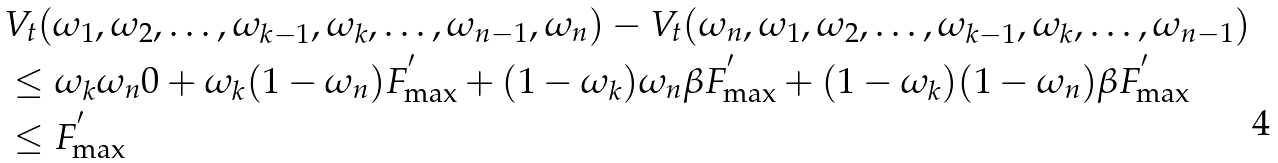<formula> <loc_0><loc_0><loc_500><loc_500>& V _ { t } ( \omega _ { 1 } , \omega _ { 2 } , \dots , \omega _ { k - 1 } , \omega _ { k } , \dots , \omega _ { n - 1 } , \omega _ { n } ) - V _ { t } ( \omega _ { n } , \omega _ { 1 } , \omega _ { 2 } , \dots , \omega _ { k - 1 } , \omega _ { k } , \dots , \omega _ { n - 1 } ) \\ & \leq \omega _ { k } \omega _ { n } 0 + \omega _ { k } ( 1 - \omega _ { n } ) F _ { \max } ^ { ^ { \prime } } + ( 1 - \omega _ { k } ) \omega _ { n } \beta F _ { \max } ^ { ^ { \prime } } + ( 1 - \omega _ { k } ) ( 1 - \omega _ { n } ) \beta F _ { \max } ^ { ^ { \prime } } \\ & \leq F _ { \max } ^ { ^ { \prime } }</formula> 